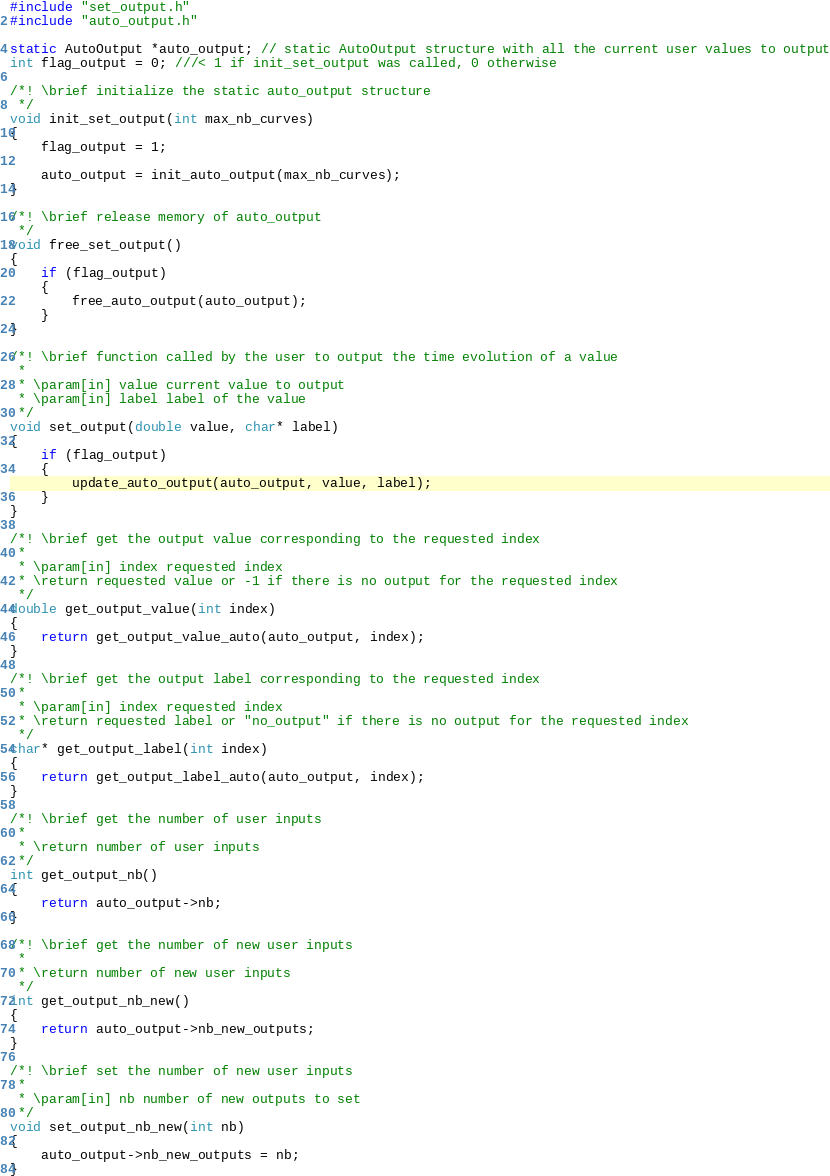<code> <loc_0><loc_0><loc_500><loc_500><_C_>
#include "set_output.h"
#include "auto_output.h"

static AutoOutput *auto_output; // static AutoOutput structure with all the current user values to output
int flag_output = 0; ///< 1 if init_set_output was called, 0 otherwise

/*! \brief initialize the static auto_output structure
 */
void init_set_output(int max_nb_curves)
{
    flag_output = 1;

    auto_output = init_auto_output(max_nb_curves);
}

/*! \brief release memory of auto_output
 */
void free_set_output()
{
    if (flag_output)
    {
        free_auto_output(auto_output);
    }
}

/*! \brief function called by the user to output the time evolution of a value
 * 
 * \param[in] value current value to output
 * \param[in] label label of the value
 */
void set_output(double value, char* label)
{
    if (flag_output)
    {
        update_auto_output(auto_output, value, label);
    }
}

/*! \brief get the output value corresponding to the requested index
 * 
 * \param[in] index requested index
 * \return requested value or -1 if there is no output for the requested index
 */
double get_output_value(int index)
{
    return get_output_value_auto(auto_output, index);
}

/*! \brief get the output label corresponding to the requested index
 * 
 * \param[in] index requested index
 * \return requested label or "no_output" if there is no output for the requested index
 */
char* get_output_label(int index)
{
    return get_output_label_auto(auto_output, index);
}

/*! \brief get the number of user inputs
 * 
 * \return number of user inputs
 */
int get_output_nb()
{
    return auto_output->nb;
}

/*! \brief get the number of new user inputs
 * 
 * \return number of new user inputs
 */
int get_output_nb_new()
{
    return auto_output->nb_new_outputs;
}

/*! \brief set the number of new user inputs
 * 
 * \param[in] nb number of new outputs to set
 */
void set_output_nb_new(int nb)
{
    auto_output->nb_new_outputs = nb;
}
</code> 